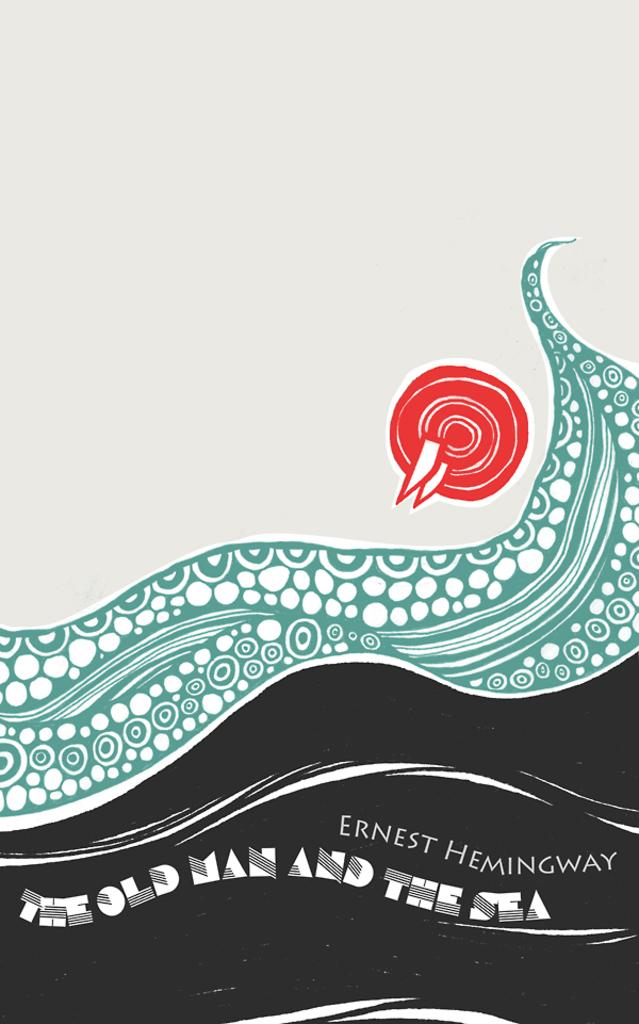<image>
Create a compact narrative representing the image presented. The cover of an Earnest Hemingway book has a blue wave on it. 